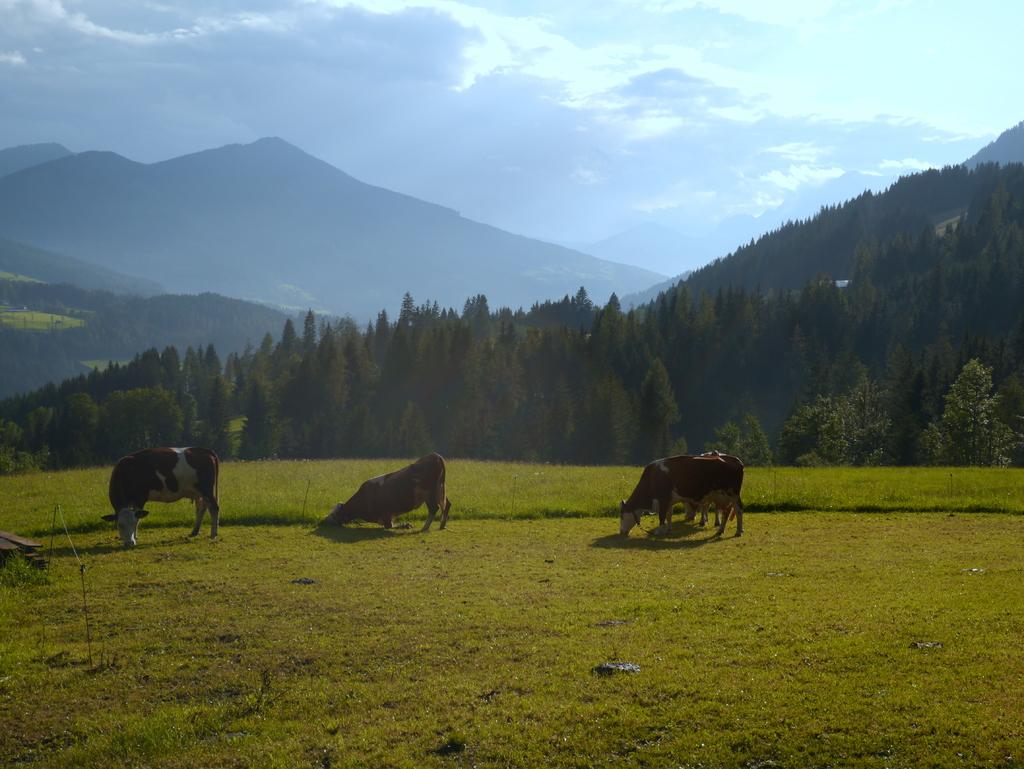What animals can be seen in the image? There are cows in the image. What type of vegetation is present in the image? There are trees in the image. What geographical features can be observed in the image? There are hills in the image. How would you describe the sky in the image? The sky is blue and cloudy. What is covering the ground in the image? Grass is present on the ground. What type of glass object can be seen in the hands of the cows in the image? There are no glass objects or cows holding objects in the image. 